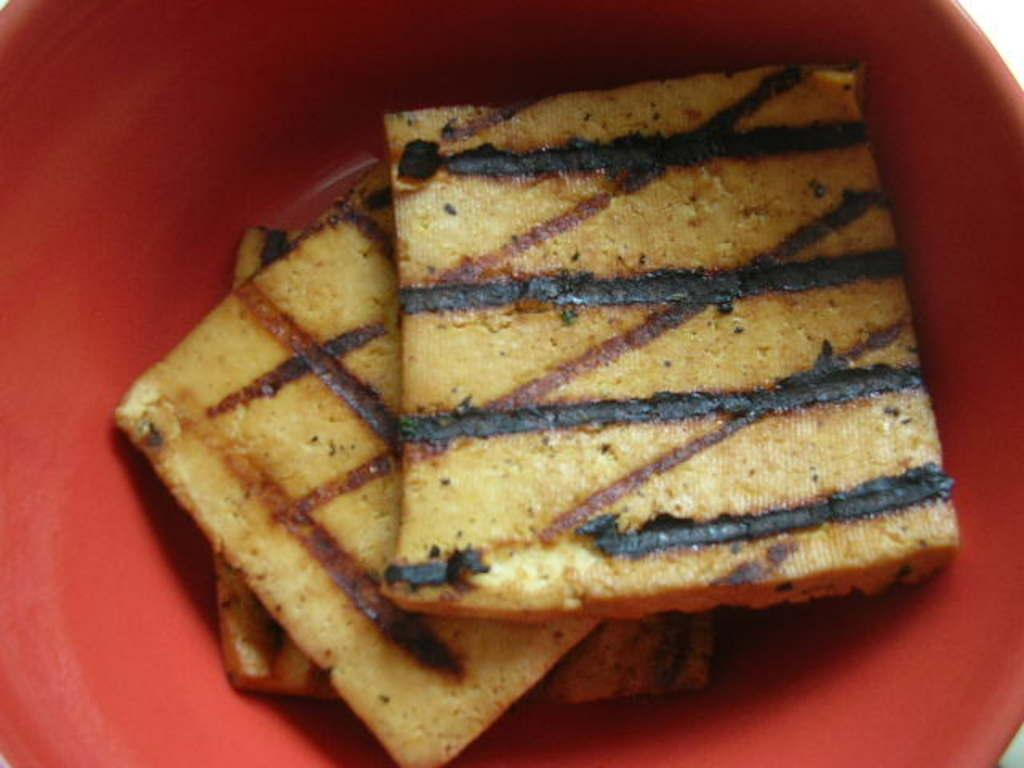What color is the bowl in the image? The bowl in the image is red. What is inside the bowl? There are food items in the bowl. What type of food items can be seen in the bowl? The food items look like bread. Is there a crown on top of the bread in the image? No, there is no crown present in the image. 